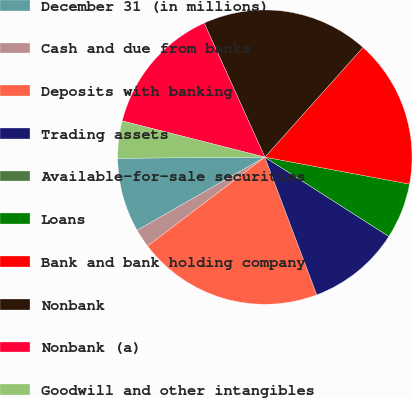<chart> <loc_0><loc_0><loc_500><loc_500><pie_chart><fcel>December 31 (in millions)<fcel>Cash and due from banks<fcel>Deposits with banking<fcel>Trading assets<fcel>Available-for-sale securities<fcel>Loans<fcel>Bank and bank holding company<fcel>Nonbank<fcel>Nonbank (a)<fcel>Goodwill and other intangibles<nl><fcel>8.16%<fcel>2.04%<fcel>20.41%<fcel>10.2%<fcel>0.0%<fcel>6.12%<fcel>16.32%<fcel>18.37%<fcel>14.28%<fcel>4.08%<nl></chart> 